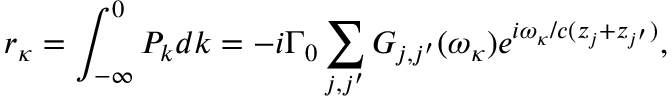Convert formula to latex. <formula><loc_0><loc_0><loc_500><loc_500>r _ { \kappa } = \int _ { - \infty } ^ { 0 } P _ { k } d k = - i \Gamma _ { 0 } \sum _ { j , j ^ { \prime } } G _ { j , j ^ { \prime } } ( \omega _ { \kappa } ) e ^ { i \omega _ { \kappa } / c ( z _ { j } + z _ { j ^ { \prime } } ) } ,</formula> 